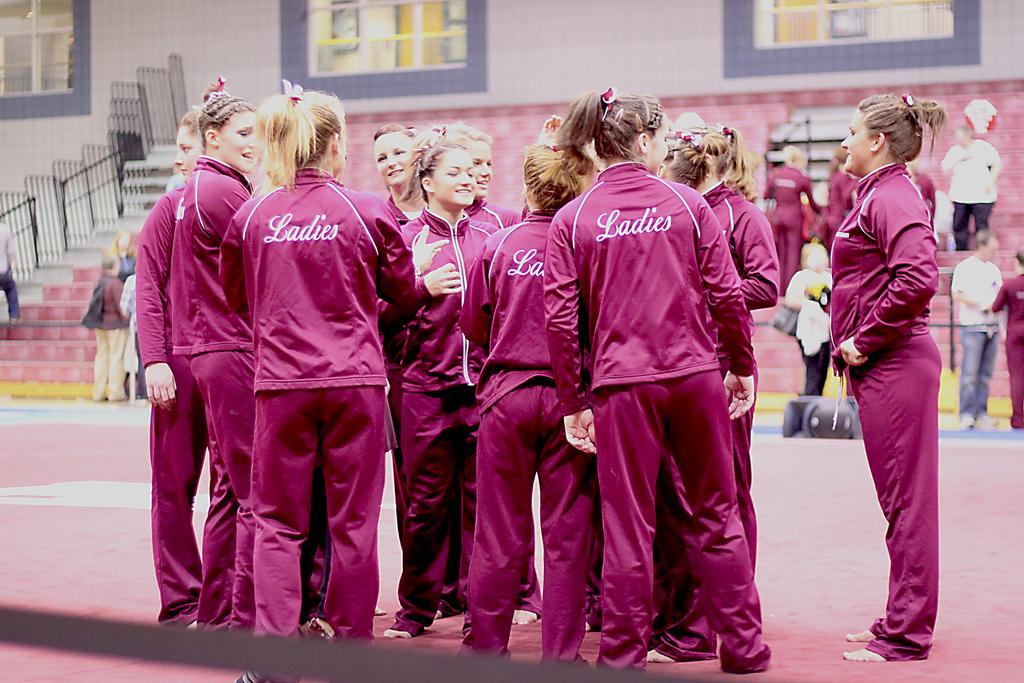<image>
Create a compact narrative representing the image presented. A team of young women has gathered wearing matching pink jumpsuits that say "Ladies" on the back. 